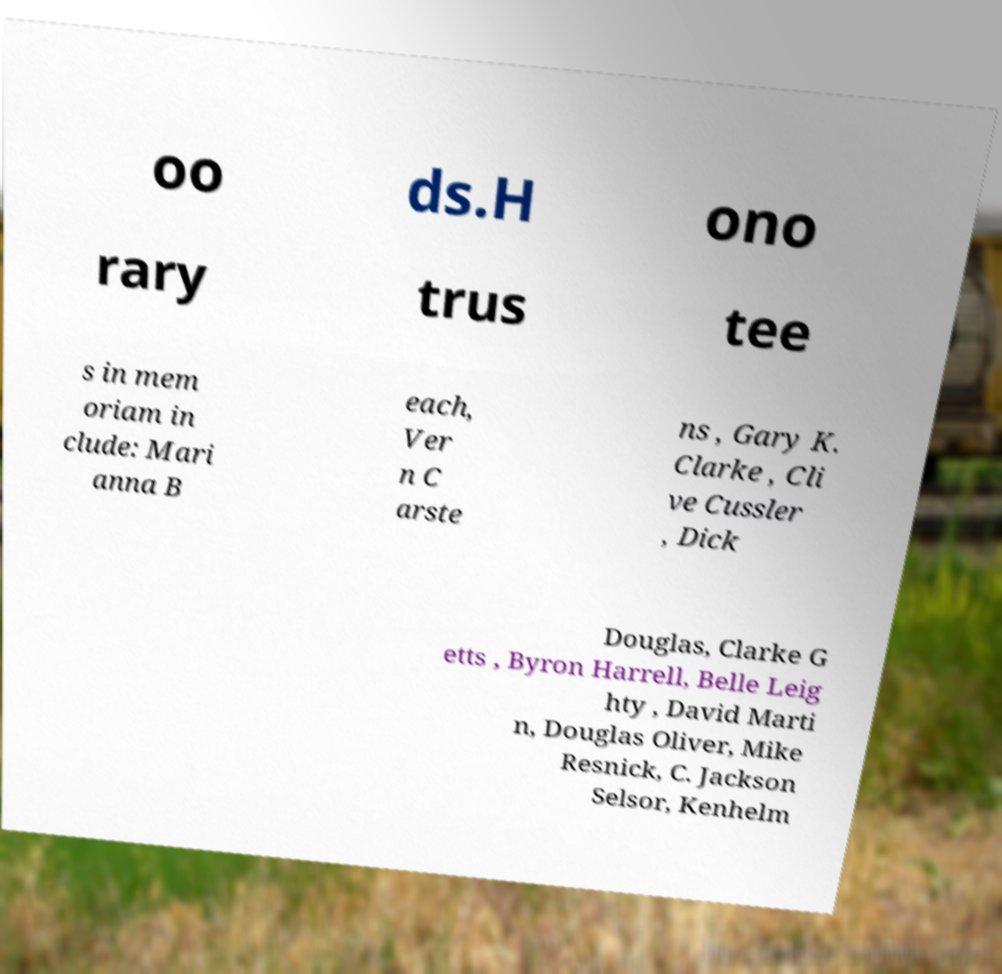Can you read and provide the text displayed in the image?This photo seems to have some interesting text. Can you extract and type it out for me? oo ds.H ono rary trus tee s in mem oriam in clude: Mari anna B each, Ver n C arste ns , Gary K. Clarke , Cli ve Cussler , Dick Douglas, Clarke G etts , Byron Harrell, Belle Leig hty , David Marti n, Douglas Oliver, Mike Resnick, C. Jackson Selsor, Kenhelm 